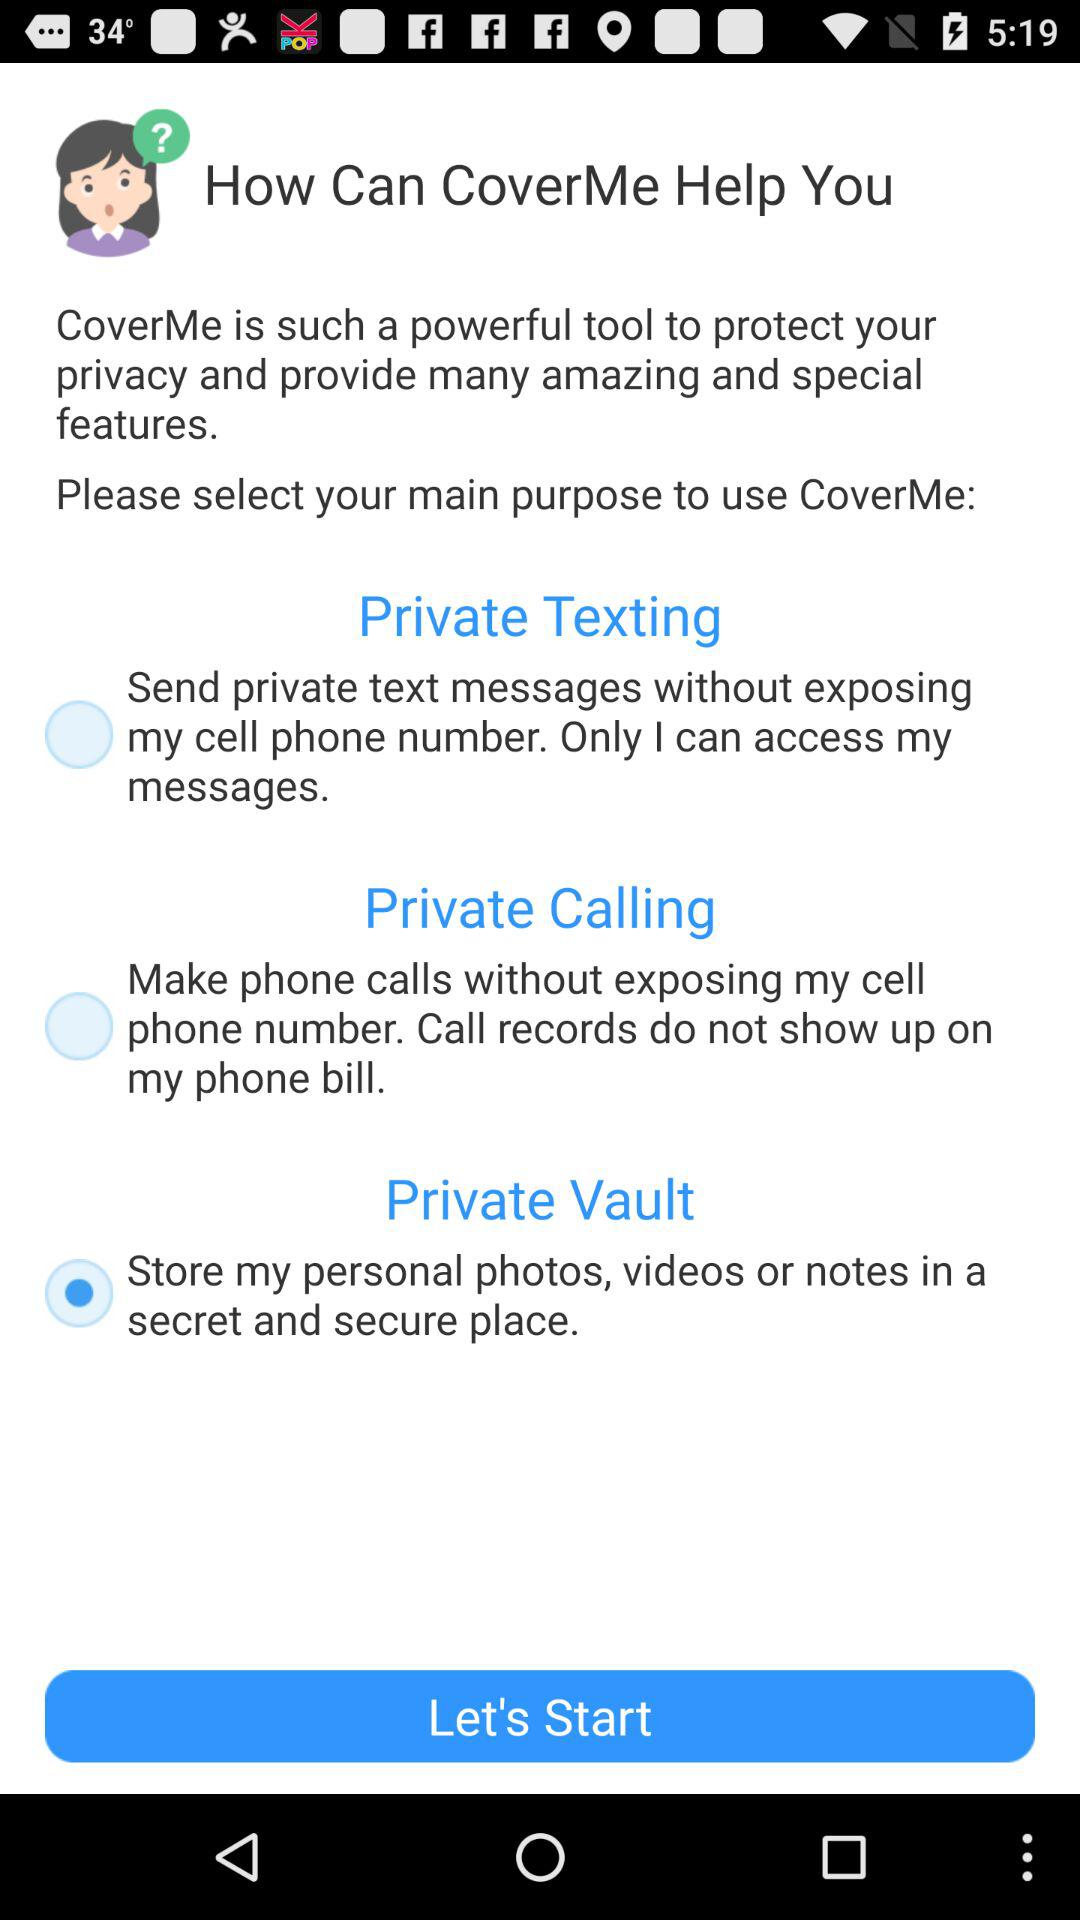Which version number of "CoverMe" is this?
When the provided information is insufficient, respond with <no answer>. <no answer> 